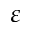Convert formula to latex. <formula><loc_0><loc_0><loc_500><loc_500>\varepsilon</formula> 